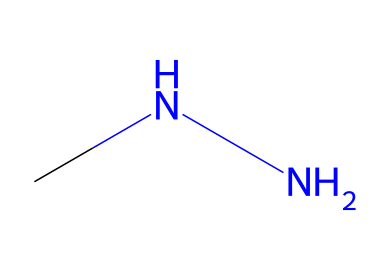What is the chemical formula of monomethylhydrazine? The SMILES representation "CNN" indicates that the chemical consists of two nitrogen atoms (N) and four hydrogen atoms (H) connected to one carbon atom (C), which makes the chemical formula C2H8N2.
Answer: C2H8N2 How many nitrogen atoms are present in monomethylhydrazine? The structure derived from the SMILES shows two nitrogen atoms connected to the carbon backbone.
Answer: 2 What type of functional group is present in monomethylhydrazine? The presence of nitrogen atoms bonded to hydrogens suggests that the chemical is an amine, specifically a primary hydrazine, as both nitrogen atoms are connected to further atoms without any double bonds.
Answer: amine What is the role of monomethylhydrazine in early aerospace development? Monomethylhydrazine served as a hypergolic propellant, which ignites spontaneously upon contact with an oxidizer, making it valuable for early aerospace propulsion systems.
Answer: hypergolic propellant Which element is central in the structure of monomethylhydrazine? The central element in the SMILES representation is carbon, as it forms the backbone of the molecule, connecting to nitrogen and hydrogen atoms.
Answer: carbon 